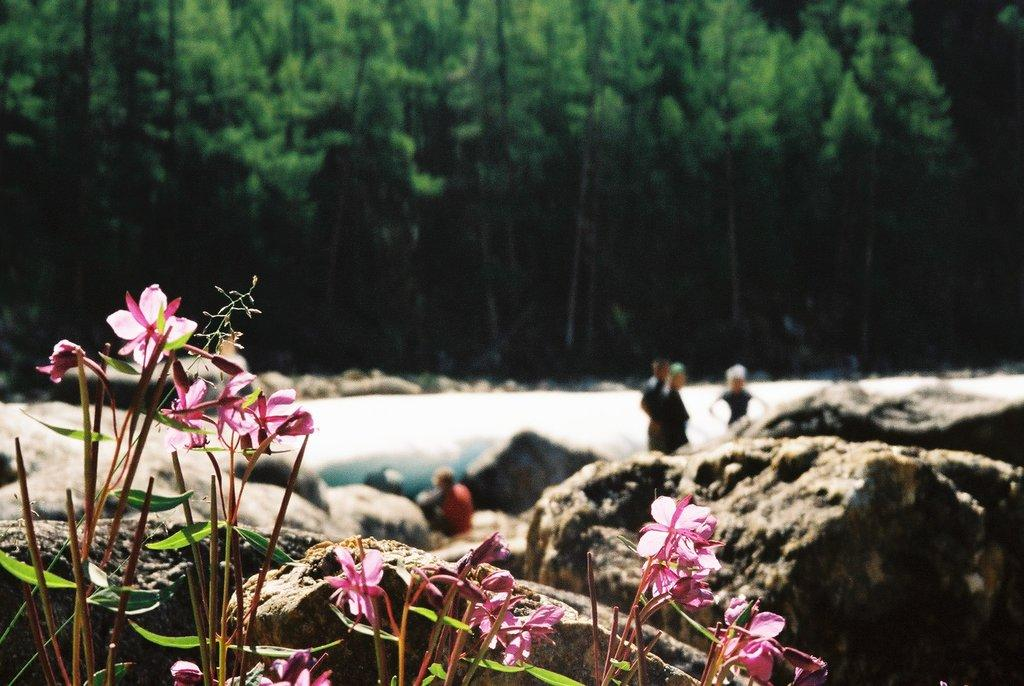What type of vegetation is in the front of the image? There are flower plants in the front of the image. What is located behind the flower plants? There are rocks behind the flower plants. Can you describe the people in the image? There are people standing in the back of the image. What can be seen in the distance in the image? There are trees in the background of the image. What type of animal is behaving strangely in the image? There are no animals present in the image, and therefore no behavior can be observed. What causes the flower plants to burst in the image? The flower plants do not burst in the image; they are depicted as standing plants. 